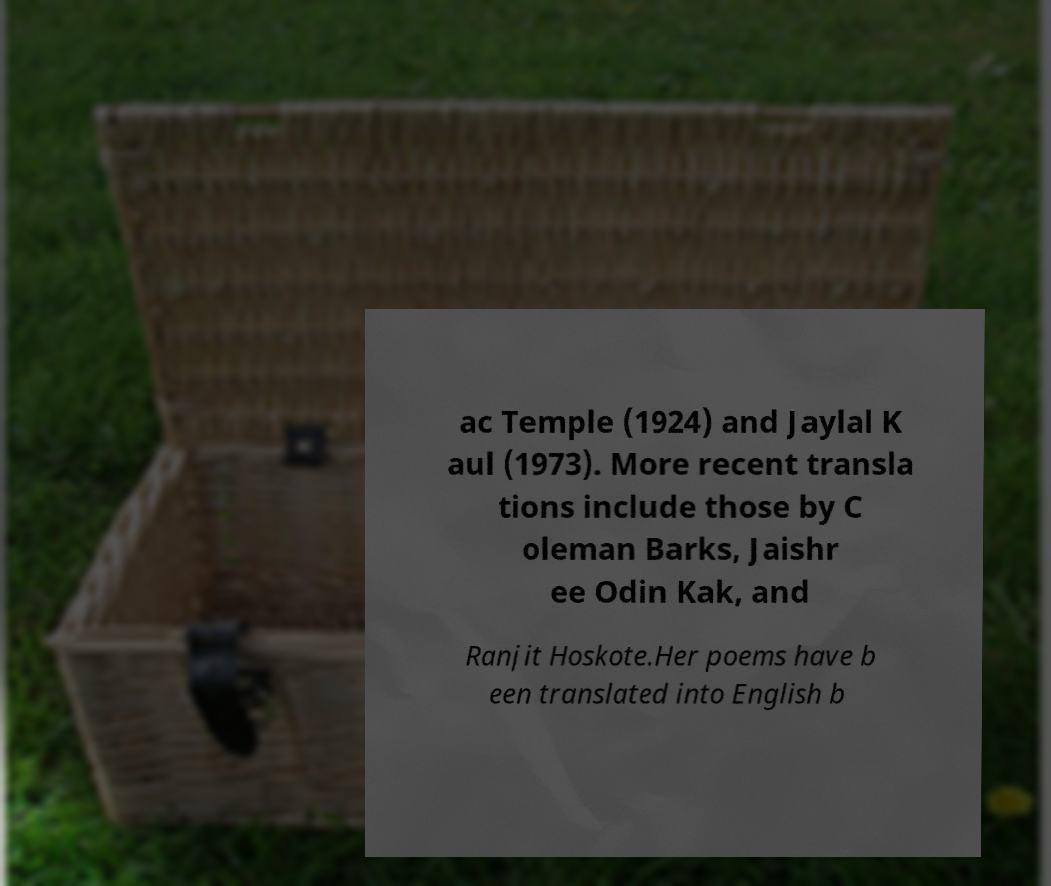I need the written content from this picture converted into text. Can you do that? ac Temple (1924) and Jaylal K aul (1973). More recent transla tions include those by C oleman Barks, Jaishr ee Odin Kak, and Ranjit Hoskote.Her poems have b een translated into English b 